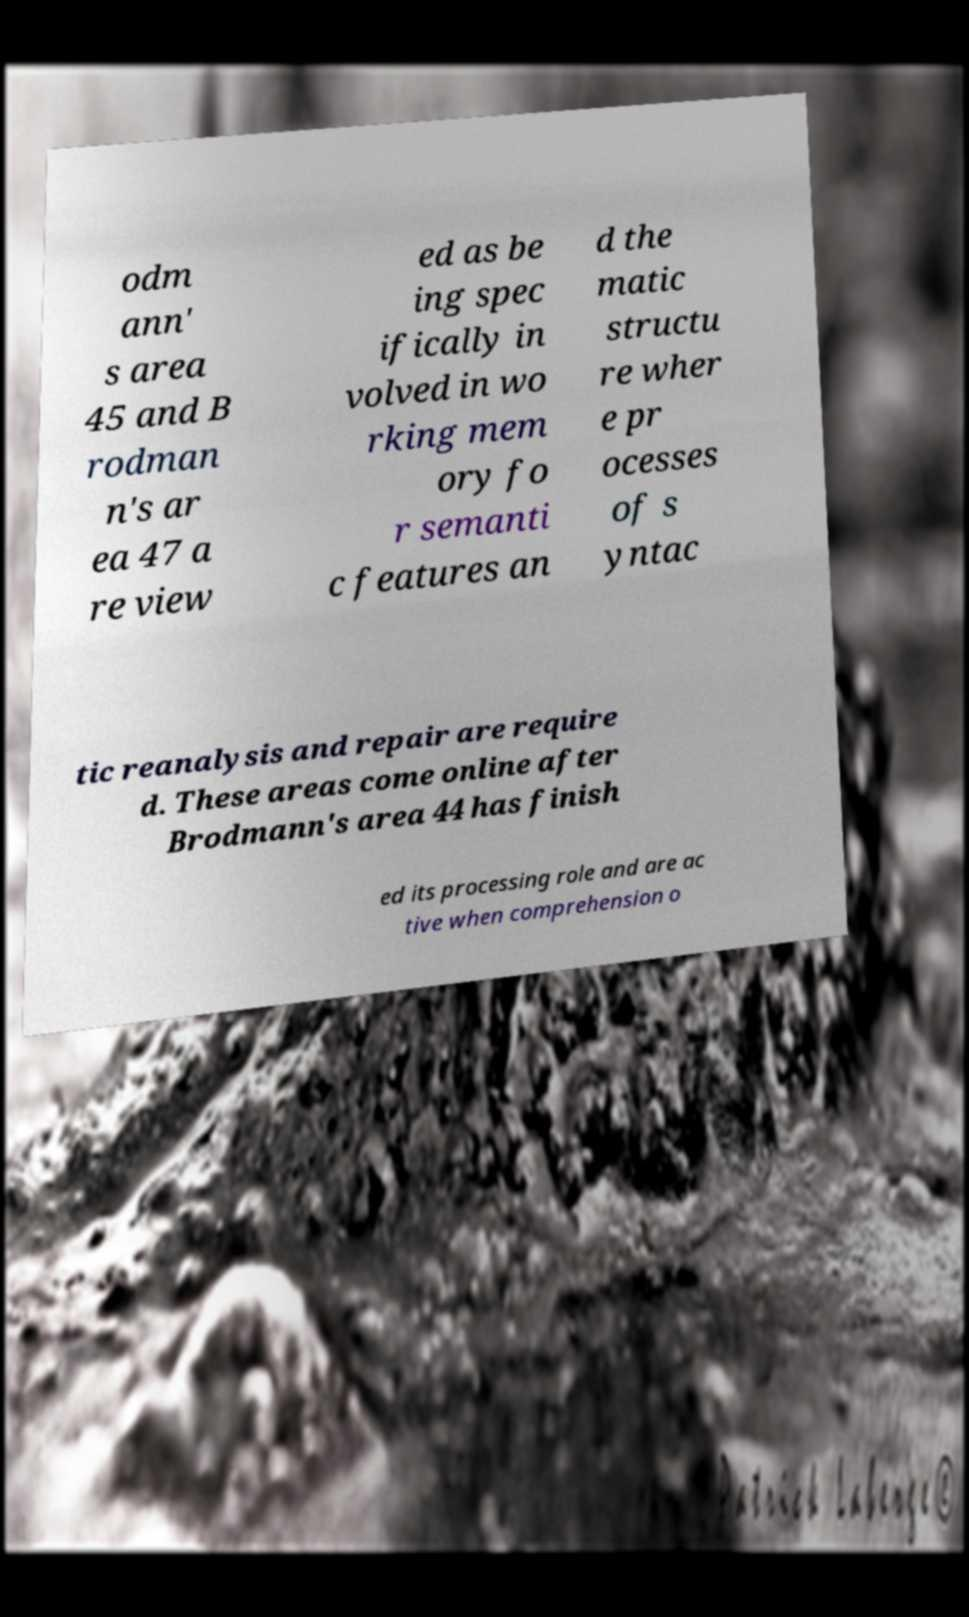Could you extract and type out the text from this image? odm ann' s area 45 and B rodman n's ar ea 47 a re view ed as be ing spec ifically in volved in wo rking mem ory fo r semanti c features an d the matic structu re wher e pr ocesses of s yntac tic reanalysis and repair are require d. These areas come online after Brodmann's area 44 has finish ed its processing role and are ac tive when comprehension o 